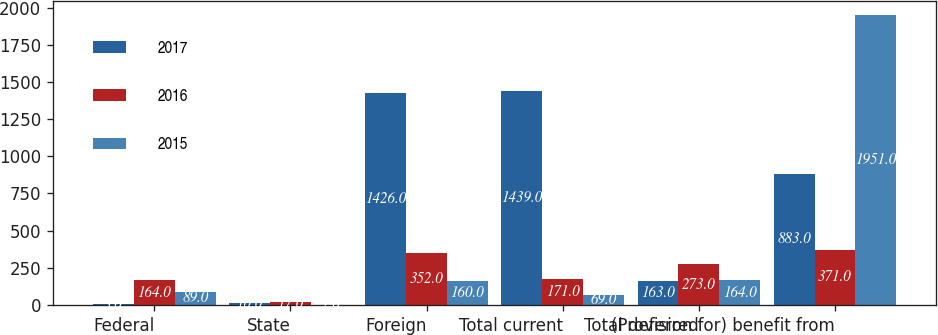Convert chart to OTSL. <chart><loc_0><loc_0><loc_500><loc_500><stacked_bar_chart><ecel><fcel>Federal<fcel>State<fcel>Foreign<fcel>Total current<fcel>Total deferred<fcel>(Provision for) benefit from<nl><fcel>2017<fcel>3<fcel>10<fcel>1426<fcel>1439<fcel>163<fcel>883<nl><fcel>2016<fcel>164<fcel>17<fcel>352<fcel>171<fcel>273<fcel>371<nl><fcel>2015<fcel>89<fcel>2<fcel>160<fcel>69<fcel>164<fcel>1951<nl></chart> 